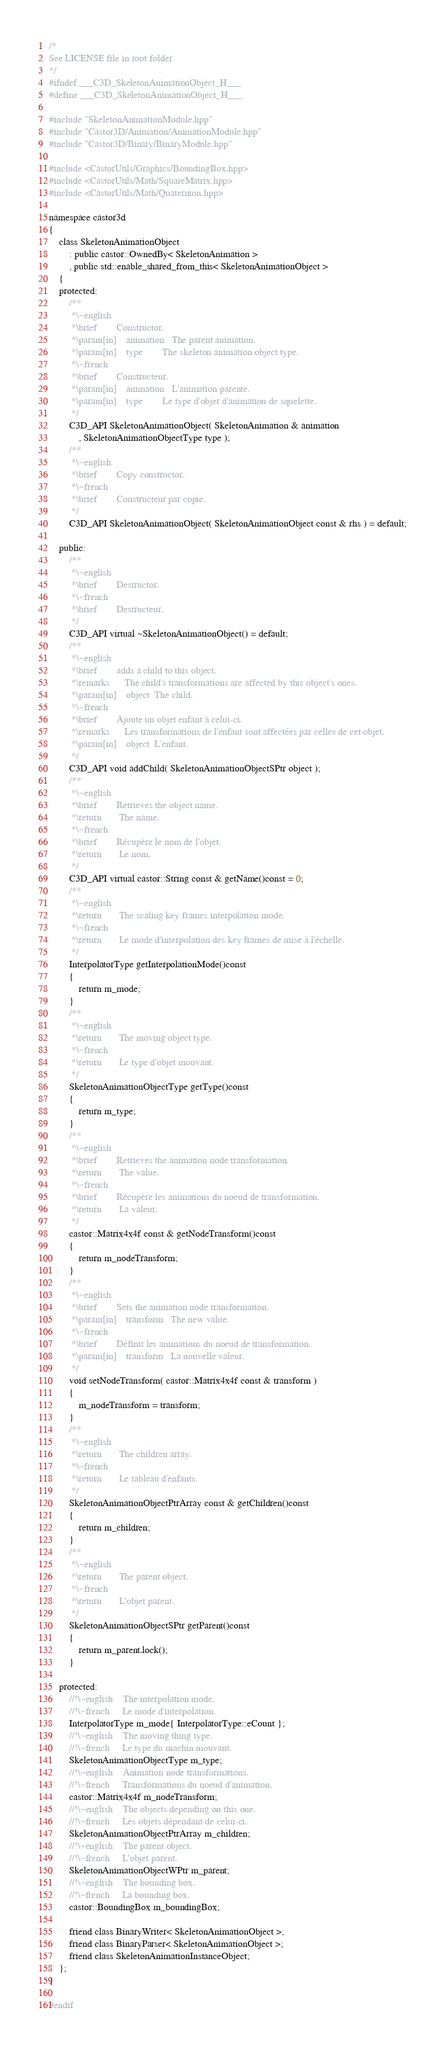Convert code to text. <code><loc_0><loc_0><loc_500><loc_500><_C++_>/*
See LICENSE file in root folder
*/
#ifndef ___C3D_SkeletonAnimationObject_H___
#define ___C3D_SkeletonAnimationObject_H___

#include "SkeletonAnimationModule.hpp"
#include "Castor3D/Animation/AnimationModule.hpp"
#include "Castor3D/Binary/BinaryModule.hpp"

#include <CastorUtils/Graphics/BoundingBox.hpp>
#include <CastorUtils/Math/SquareMatrix.hpp>
#include <CastorUtils/Math/Quaternion.hpp>

namespace castor3d
{
	class SkeletonAnimationObject
		: public castor::OwnedBy< SkeletonAnimation >
		, public std::enable_shared_from_this< SkeletonAnimationObject >
	{
	protected:
		/**
		 *\~english
		 *\brief		Constructor.
		 *\param[in]	animation	The parent animation.
		 *\param[in]	type		The skeleton animation object type.
		 *\~french
		 *\brief		Constructeur.
		 *\param[in]	animation	L'animation parente.
		 *\param[in]	type		Le type d'objet d'animation de squelette.
		 */
		C3D_API SkeletonAnimationObject( SkeletonAnimation & animation
			, SkeletonAnimationObjectType type );
		/**
		 *\~english
		 *\brief		Copy constructor.
		 *\~french
		 *\brief		Constructeur par copie.
		 */
		C3D_API SkeletonAnimationObject( SkeletonAnimationObject const & rhs ) = default;

	public:
		/**
		 *\~english
		 *\brief		Destructor.
		 *\~french
		 *\brief		Destructeur.
		 */
		C3D_API virtual ~SkeletonAnimationObject() = default;
		/**
		 *\~english
		 *\brief		adds a child to this object.
		 *\remarks		The child's transformations are affected by this object's ones.
		 *\param[in]	object	The child.
		 *\~french
		 *\brief		Ajoute un objet enfant à celui-ci.
		 *\remarks		Les transformations de l'enfant sont affectées par celles de cet objet.
		 *\param[in]	object	L'enfant.
		 */
		C3D_API void addChild( SkeletonAnimationObjectSPtr object );
		/**
		 *\~english
		 *\brief		Retrieves the object name.
		 *\return		The name.
		 *\~french
		 *\brief		Récupère le nom de l'objet.
		 *\return		Le nom.
		 */
		C3D_API virtual castor::String const & getName()const = 0;
		/**
		 *\~english
		 *\return		The scaling key frames interpolation mode.
		 *\~french
		 *\return		Le mode d'interpolation des key frames de mise à l'échelle.
		 */
		InterpolatorType getInterpolationMode()const
		{
			return m_mode;
		}
		/**
		 *\~english
		 *\return		The moving object type.
		 *\~french
		 *\return		Le type d'objet mouvant.
		 */
		SkeletonAnimationObjectType getType()const
		{
			return m_type;
		}
		/**
		 *\~english
		 *\brief		Retrieves the animation node transformation.
		 *\return		The value.
		 *\~french
		 *\brief		Récupère les animations du noeud de transformation.
		 *\return		La valeur.
		 */
		castor::Matrix4x4f const & getNodeTransform()const
		{
			return m_nodeTransform;
		}
		/**
		 *\~english
		 *\brief		Sets the animation node transformation.
		 *\param[in]	transform	The new value.
		 *\~french
		 *\brief		Définit les animations du noeud de transformation.
		 *\param[in]	transform	La nouvelle valeur.
		 */
		void setNodeTransform( castor::Matrix4x4f const & transform )
		{
			m_nodeTransform = transform;
		}
		/**
		 *\~english
		 *\return		The children array.
		 *\~french
		 *\return		Le tableau d'enfants.
		 */
		SkeletonAnimationObjectPtrArray const & getChildren()const
		{
			return m_children;
		}
		/**
		 *\~english
		 *\return		The parent object.
		 *\~french
		 *\return		L'objet parent.
		 */
		SkeletonAnimationObjectSPtr getParent()const
		{
			return m_parent.lock();
		}

	protected:
		//!\~english	The interpolation mode.
		//!\~french		Le mode d'interpolation.
		InterpolatorType m_mode{ InterpolatorType::eCount };
		//!\~english	The moving thing type.
		//!\~french		Le type du machin mouvant.
		SkeletonAnimationObjectType m_type;
		//!\~english	Animation node transformations.
		//!\~french		Transformations du noeud d'animation.
		castor::Matrix4x4f m_nodeTransform;
		//!\~english	The objects depending on this one.
		//!\~french		Les objets dépendant de celui-ci.
		SkeletonAnimationObjectPtrArray m_children;
		//!\~english	The parent object.
		//!\~french		L'objet parent.
		SkeletonAnimationObjectWPtr m_parent;
		//!\~english	The bounding box.
		//!\~french		La bounding box.
		castor::BoundingBox m_boundingBox;

		friend class BinaryWriter< SkeletonAnimationObject >;
		friend class BinaryParser< SkeletonAnimationObject >;
		friend class SkeletonAnimationInstanceObject;
	};
}

#endif
</code> 